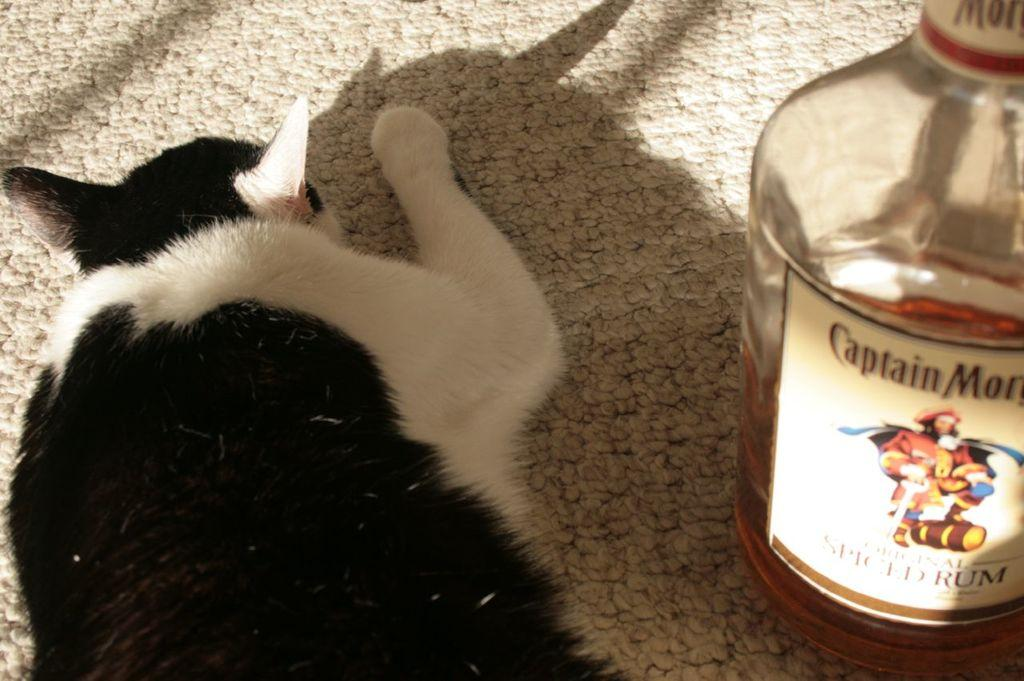What type of animal is in the image? There is a cat in the image. What is the cat doing in the image? The cat is laying on a mat. What else can be seen on the right side of the image? There is a bottle on the right side of the image. What type of pear is being used as a pillow for the cat in the image? There is no pear present in the image, and the cat is laying on a mat, not a pear. 